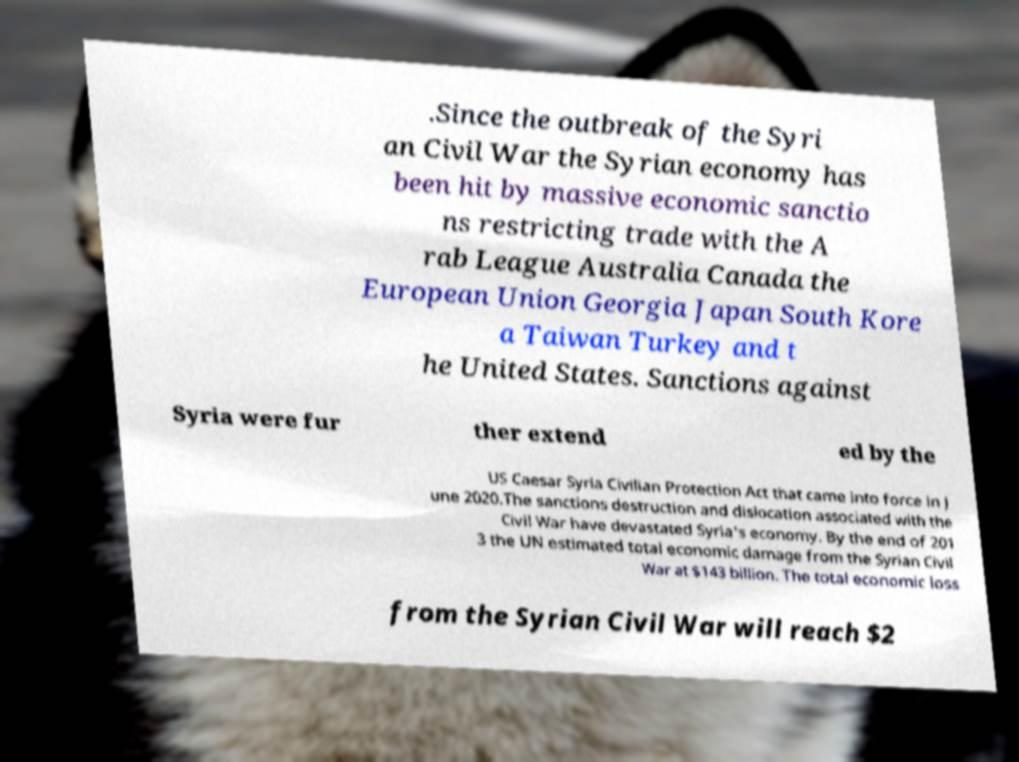What messages or text are displayed in this image? I need them in a readable, typed format. .Since the outbreak of the Syri an Civil War the Syrian economy has been hit by massive economic sanctio ns restricting trade with the A rab League Australia Canada the European Union Georgia Japan South Kore a Taiwan Turkey and t he United States. Sanctions against Syria were fur ther extend ed by the US Caesar Syria Civilian Protection Act that came into force in J une 2020.The sanctions destruction and dislocation associated with the Civil War have devastated Syria's economy. By the end of 201 3 the UN estimated total economic damage from the Syrian Civil War at $143 billion. The total economic loss from the Syrian Civil War will reach $2 